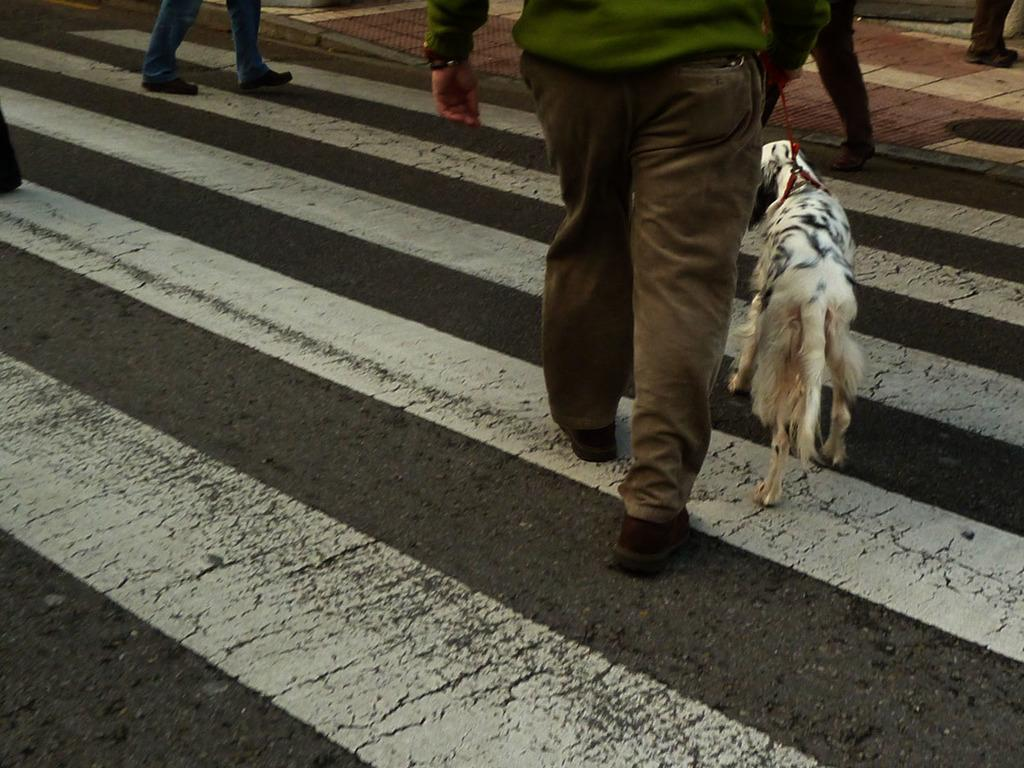What are the people in the image doing? The people in the image are walking on the road. Can you describe any other living creature in the image? Yes, there is a dog in the image. How many letters are being distributed by the people in the image? There is no mention of letters or distribution in the image; it only shows people walking on the road and a dog. 